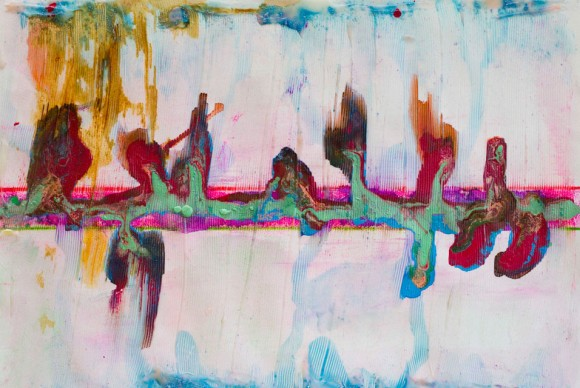What do you see happening in this image? In this image, we are presented with a striking abstract composition. The artist uses a variety of colors and shapes that seem to flow into each other, creating a dynamic and captivating visual narrative. Dominated by pastel hues, the painting exudes a sense of calm, while sporadic darker tones introduce contrast and complexity.

The abstract style is evident through the non-representational forms that challenge traditional artistic boundaries, reflecting the hallmarks of modern art. This piece potentially uses a combination of mediums, such as paint and collage, which contribute to its textured appearance, further engaging the viewer's senses.

The layout predominantly features horizontal lines, but vertical elements disrupt this consistency, adding vigor and movement to the artwork. There's also a noticeable asymmetry that enhances its abstract nature, making the composition more intriguing and unpredictable.

Overall, this abstract artwork is a vivid portrayal of the artist's exploration of color, form, and texture, inviting viewers to interpret the visual story from their unique perspectives. 